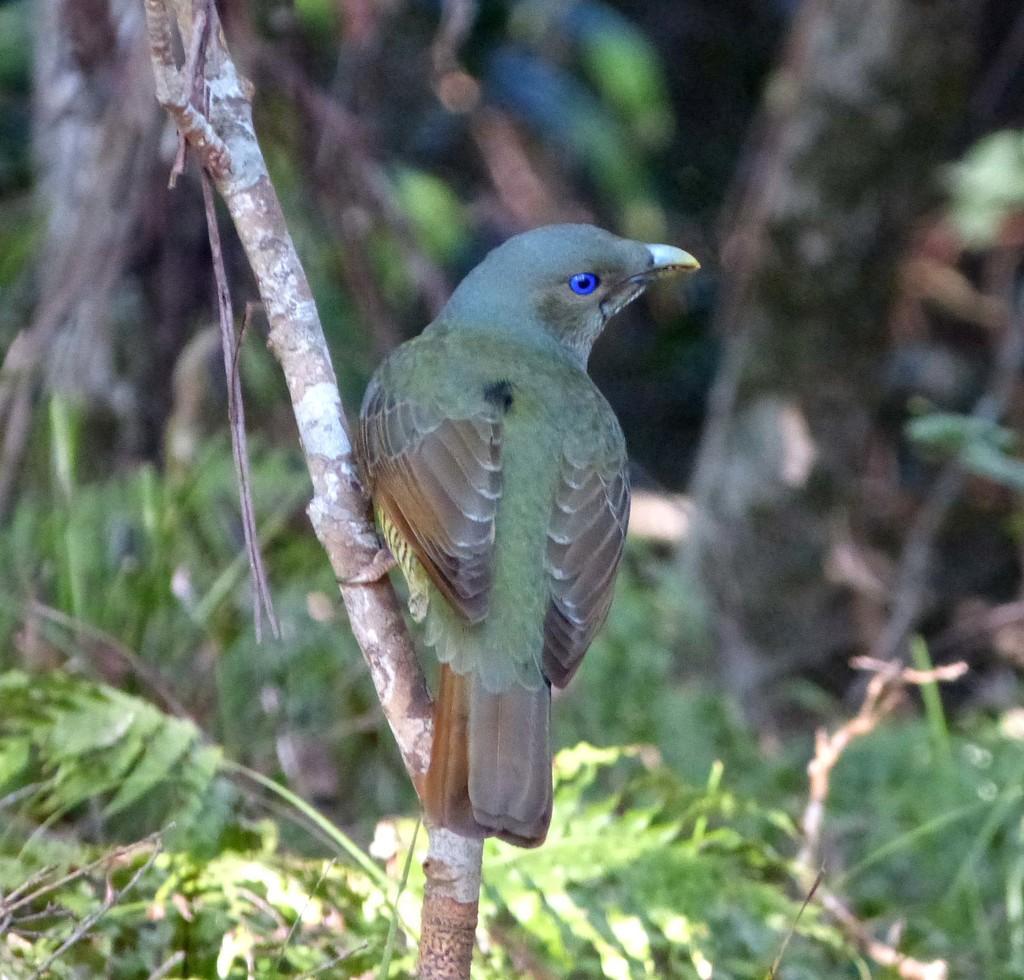Could you give a brief overview of what you see in this image? In the image we can see a bird sitting on the stem. Here we can see the leaves and the background is blurred. 